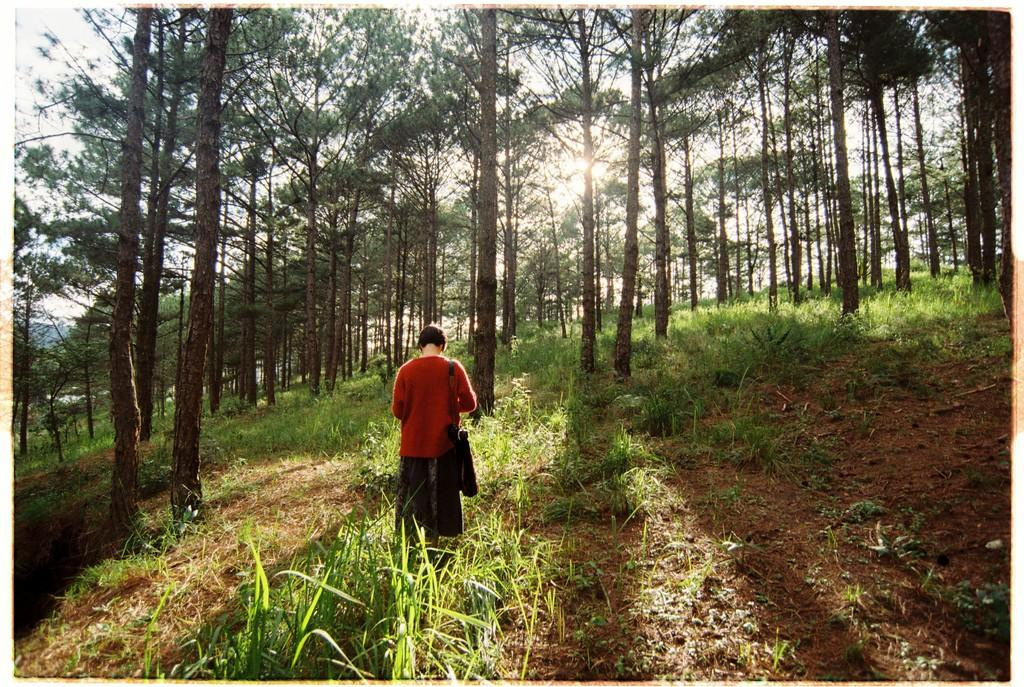Who is the main subject in the image? There is a woman in the image. What is the woman's location in the image? The woman is standing in the middle of the grassland. What can be seen in the background of the image? Trees are present in the background of the image. What type of fan is the woman holding in the image? There is no fan present in the image; the woman is standing in the grassland with no visible objects in her hands. 